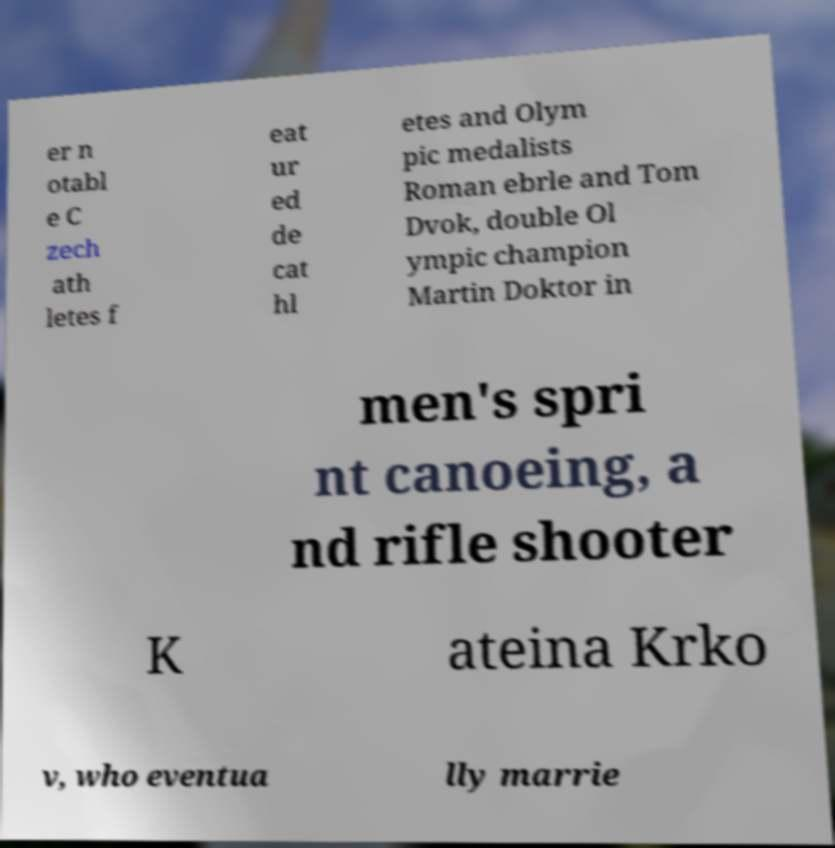There's text embedded in this image that I need extracted. Can you transcribe it verbatim? er n otabl e C zech ath letes f eat ur ed de cat hl etes and Olym pic medalists Roman ebrle and Tom Dvok, double Ol ympic champion Martin Doktor in men's spri nt canoeing, a nd rifle shooter K ateina Krko v, who eventua lly marrie 